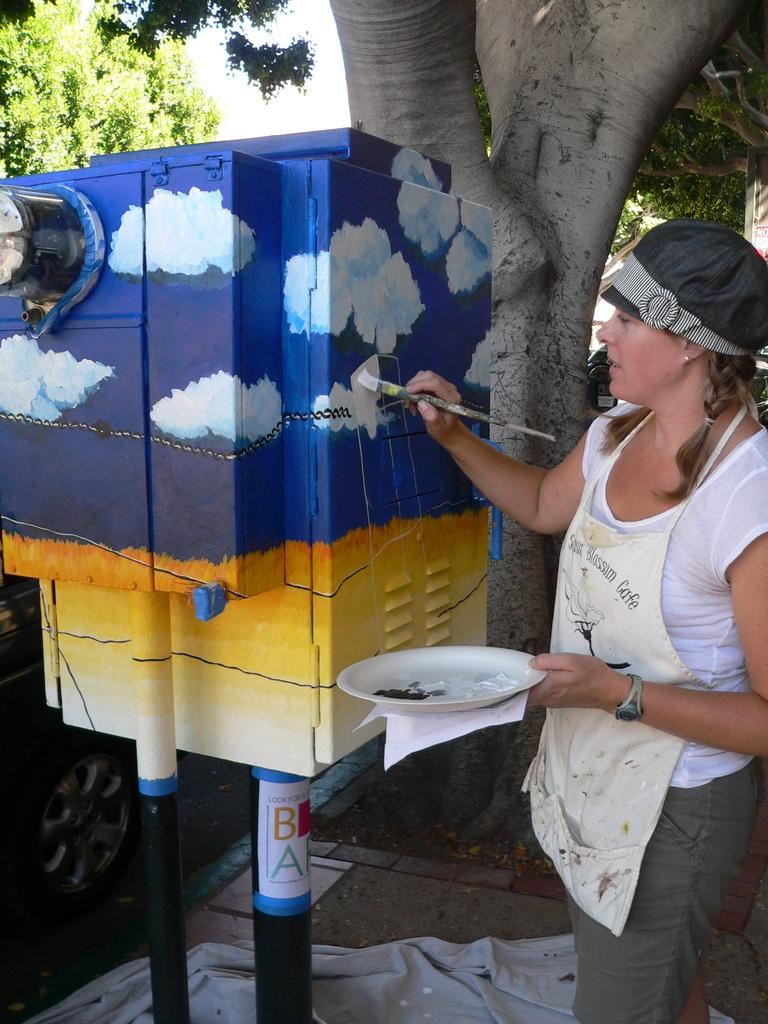Who is the main subject in the image? There is a woman in the picture. What is the woman doing in the image? The woman is painting a box. What tool is the woman using to paint? The woman is using a brush to paint. What clothing items is the woman wearing? The woman is wearing a white T-shirt, an apron, and a cap. What can be seen in the background of the image? There is a tree visible in the image. What type of bushes can be seen growing near the woman in the image? There are no bushes visible in the image; only a tree can be seen in the background. What surprise might the woman have planned for her friends in the image? There is no indication of a surprise or any friends in the image; it only shows the woman painting a box. 